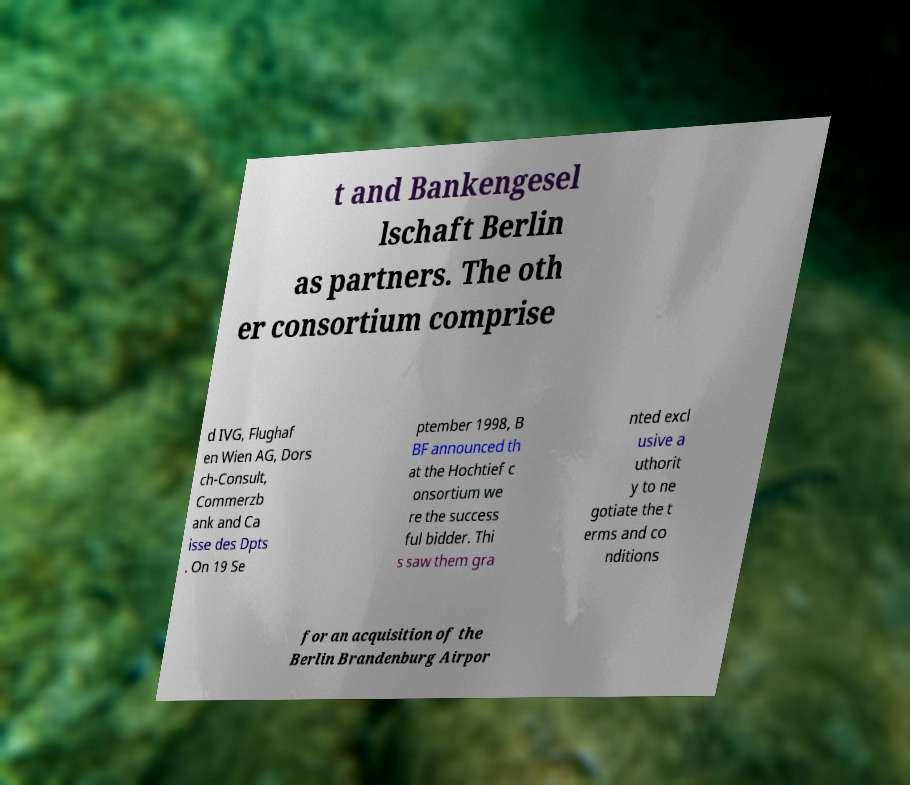Can you accurately transcribe the text from the provided image for me? t and Bankengesel lschaft Berlin as partners. The oth er consortium comprise d IVG, Flughaf en Wien AG, Dors ch-Consult, Commerzb ank and Ca isse des Dpts . On 19 Se ptember 1998, B BF announced th at the Hochtief c onsortium we re the success ful bidder. Thi s saw them gra nted excl usive a uthorit y to ne gotiate the t erms and co nditions for an acquisition of the Berlin Brandenburg Airpor 